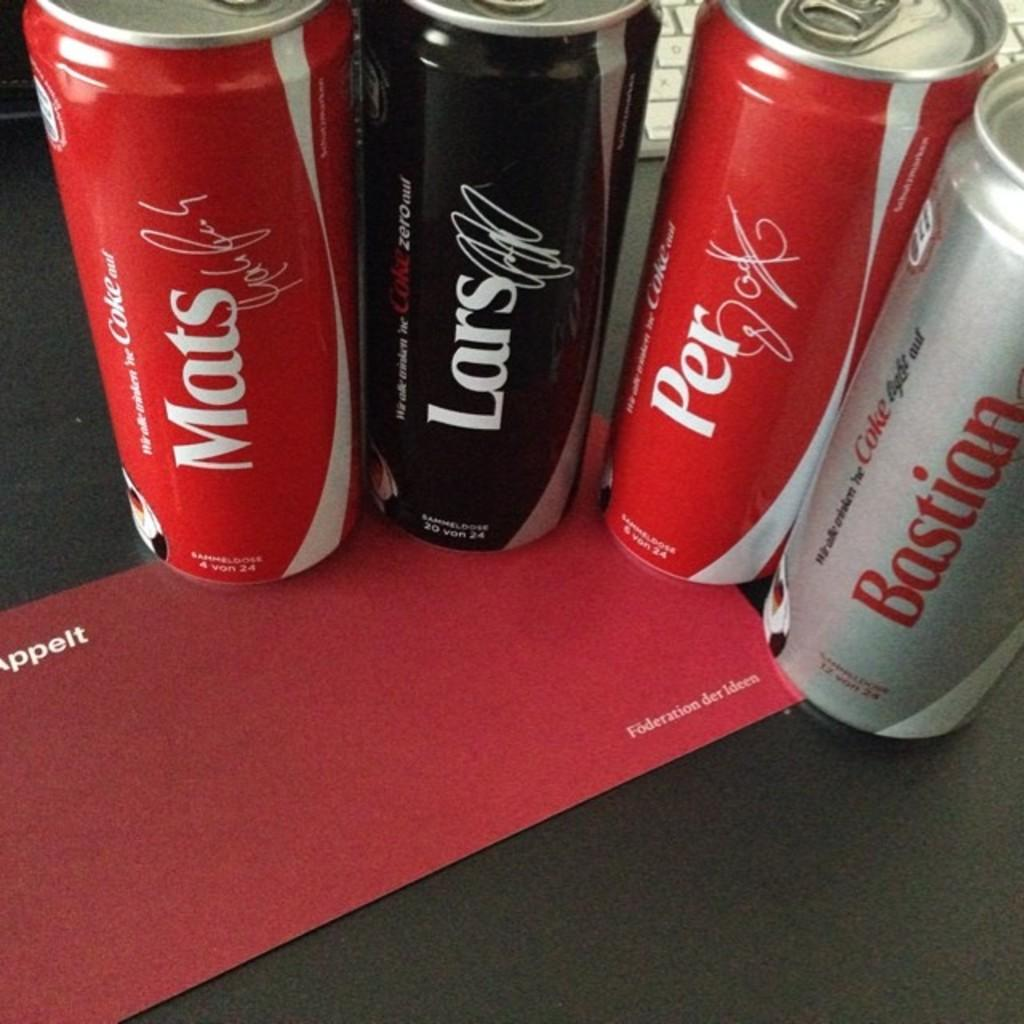<image>
Describe the image concisely. several bottles of Coke with personalized names like Mats and Lars 